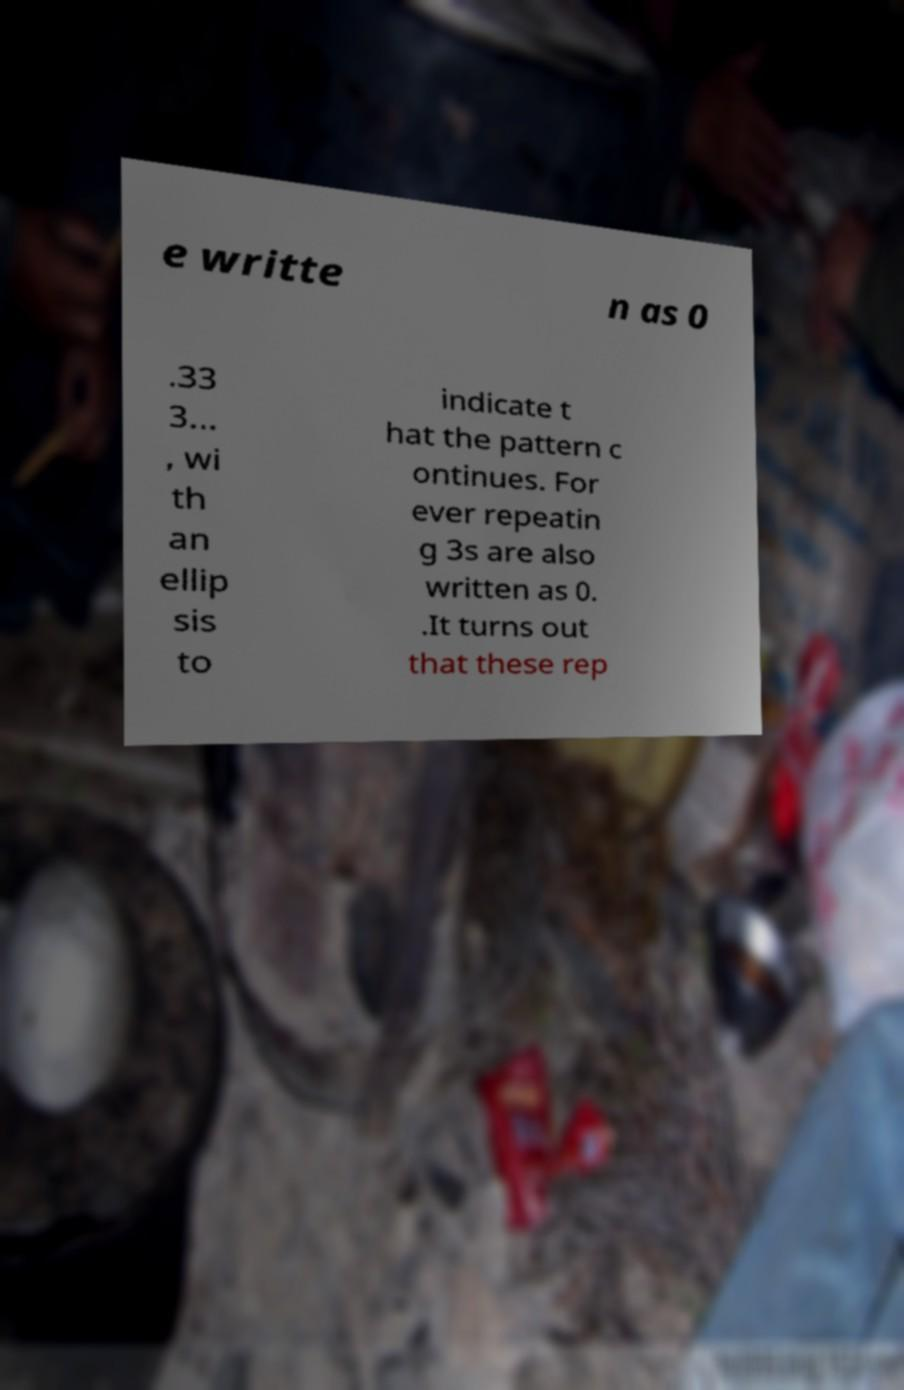I need the written content from this picture converted into text. Can you do that? e writte n as 0 .33 3... , wi th an ellip sis to indicate t hat the pattern c ontinues. For ever repeatin g 3s are also written as 0. .It turns out that these rep 